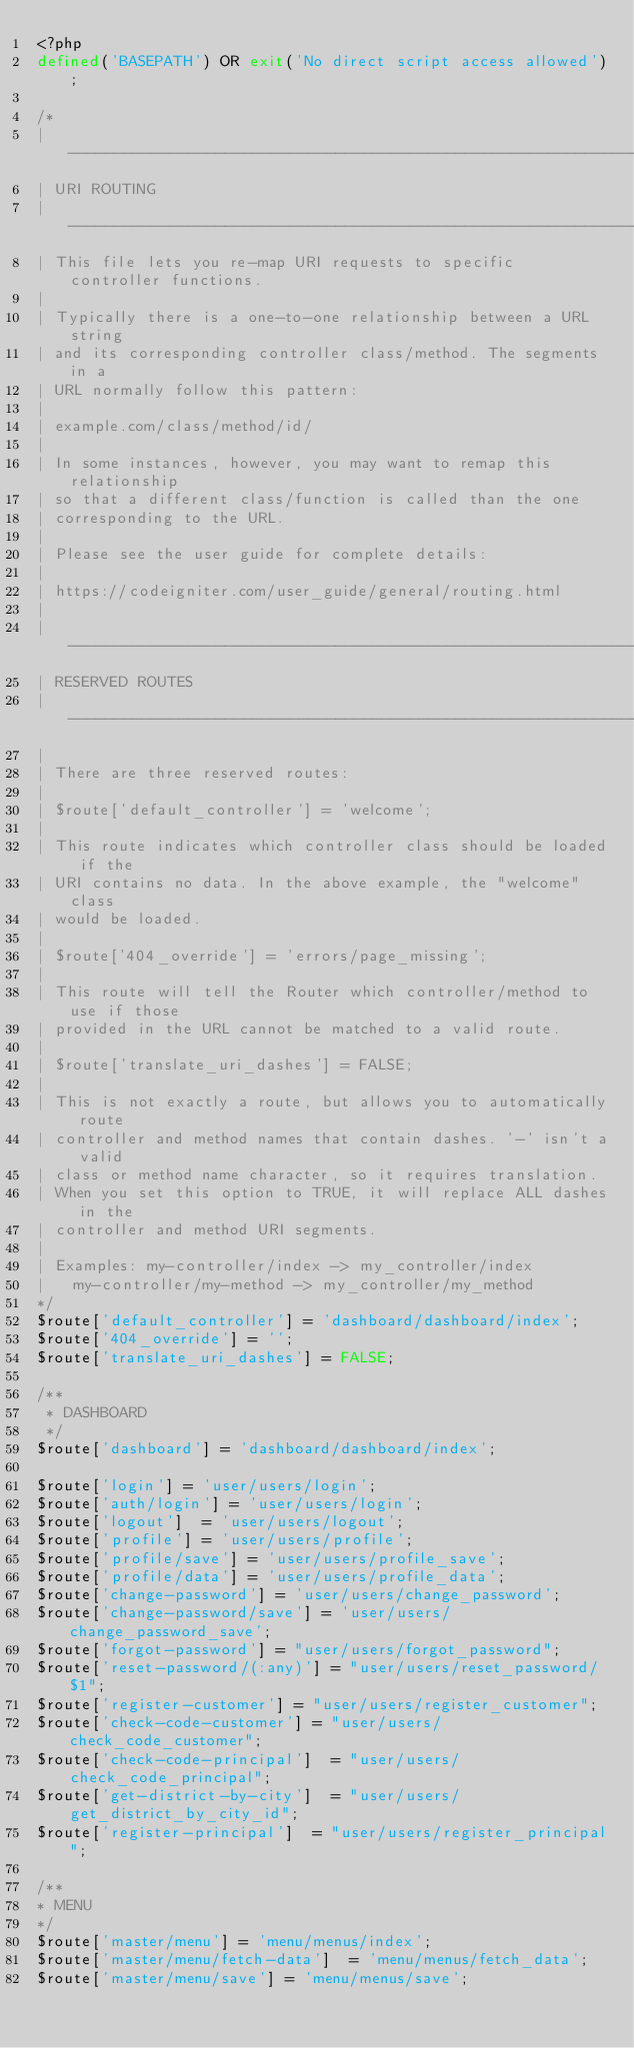<code> <loc_0><loc_0><loc_500><loc_500><_PHP_><?php
defined('BASEPATH') OR exit('No direct script access allowed');

/*
| -------------------------------------------------------------------------
| URI ROUTING
| -------------------------------------------------------------------------
| This file lets you re-map URI requests to specific controller functions.
|
| Typically there is a one-to-one relationship between a URL string
| and its corresponding controller class/method. The segments in a
| URL normally follow this pattern:
|
|	example.com/class/method/id/
|
| In some instances, however, you may want to remap this relationship
| so that a different class/function is called than the one
| corresponding to the URL.
|
| Please see the user guide for complete details:
|
|	https://codeigniter.com/user_guide/general/routing.html
|
| -------------------------------------------------------------------------
| RESERVED ROUTES
| -------------------------------------------------------------------------
|
| There are three reserved routes:
|
|	$route['default_controller'] = 'welcome';
|
| This route indicates which controller class should be loaded if the
| URI contains no data. In the above example, the "welcome" class
| would be loaded.
|
|	$route['404_override'] = 'errors/page_missing';
|
| This route will tell the Router which controller/method to use if those
| provided in the URL cannot be matched to a valid route.
|
|	$route['translate_uri_dashes'] = FALSE;
|
| This is not exactly a route, but allows you to automatically route
| controller and method names that contain dashes. '-' isn't a valid
| class or method name character, so it requires translation.
| When you set this option to TRUE, it will replace ALL dashes in the
| controller and method URI segments.
|
| Examples:	my-controller/index	-> my_controller/index
|		my-controller/my-method	-> my_controller/my_method
*/
$route['default_controller'] = 'dashboard/dashboard/index';
$route['404_override'] = '';
$route['translate_uri_dashes'] = FALSE;

/**
 * DASHBOARD
 */
$route['dashboard'] = 'dashboard/dashboard/index';
	
$route['login'] = 'user/users/login';
$route['auth/login'] = 'user/users/login';
$route['logout']	= 'user/users/logout';
$route['profile'] = 'user/users/profile';
$route['profile/save'] = 'user/users/profile_save';
$route['profile/data'] = 'user/users/profile_data';
$route['change-password'] = 'user/users/change_password';
$route['change-password/save'] = 'user/users/change_password_save';
$route['forgot-password']	= "user/users/forgot_password";
$route['reset-password/(:any)'] = "user/users/reset_password/$1";
$route['register-customer']	= "user/users/register_customer";
$route['check-code-customer']	= "user/users/check_code_customer";
$route['check-code-principal']	= "user/users/check_code_principal";
$route['get-district-by-city']	= "user/users/get_district_by_city_id";
$route['register-principal']	= "user/users/register_principal";

/**
* MENU
*/
$route['master/menu'] = 'menu/menus/index';
$route['master/menu/fetch-data']	= 'menu/menus/fetch_data';
$route['master/menu/save'] = 'menu/menus/save';</code> 